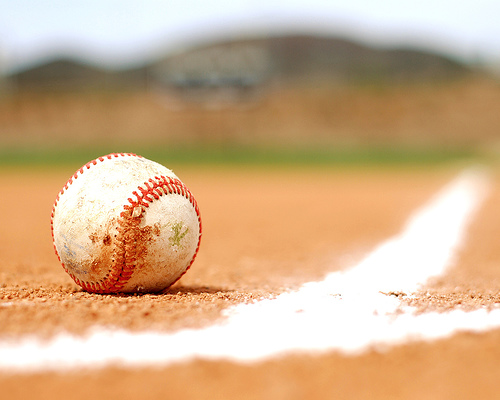<image>
Is there a baseball behind the line? Yes. From this viewpoint, the baseball is positioned behind the line, with the line partially or fully occluding the baseball. 